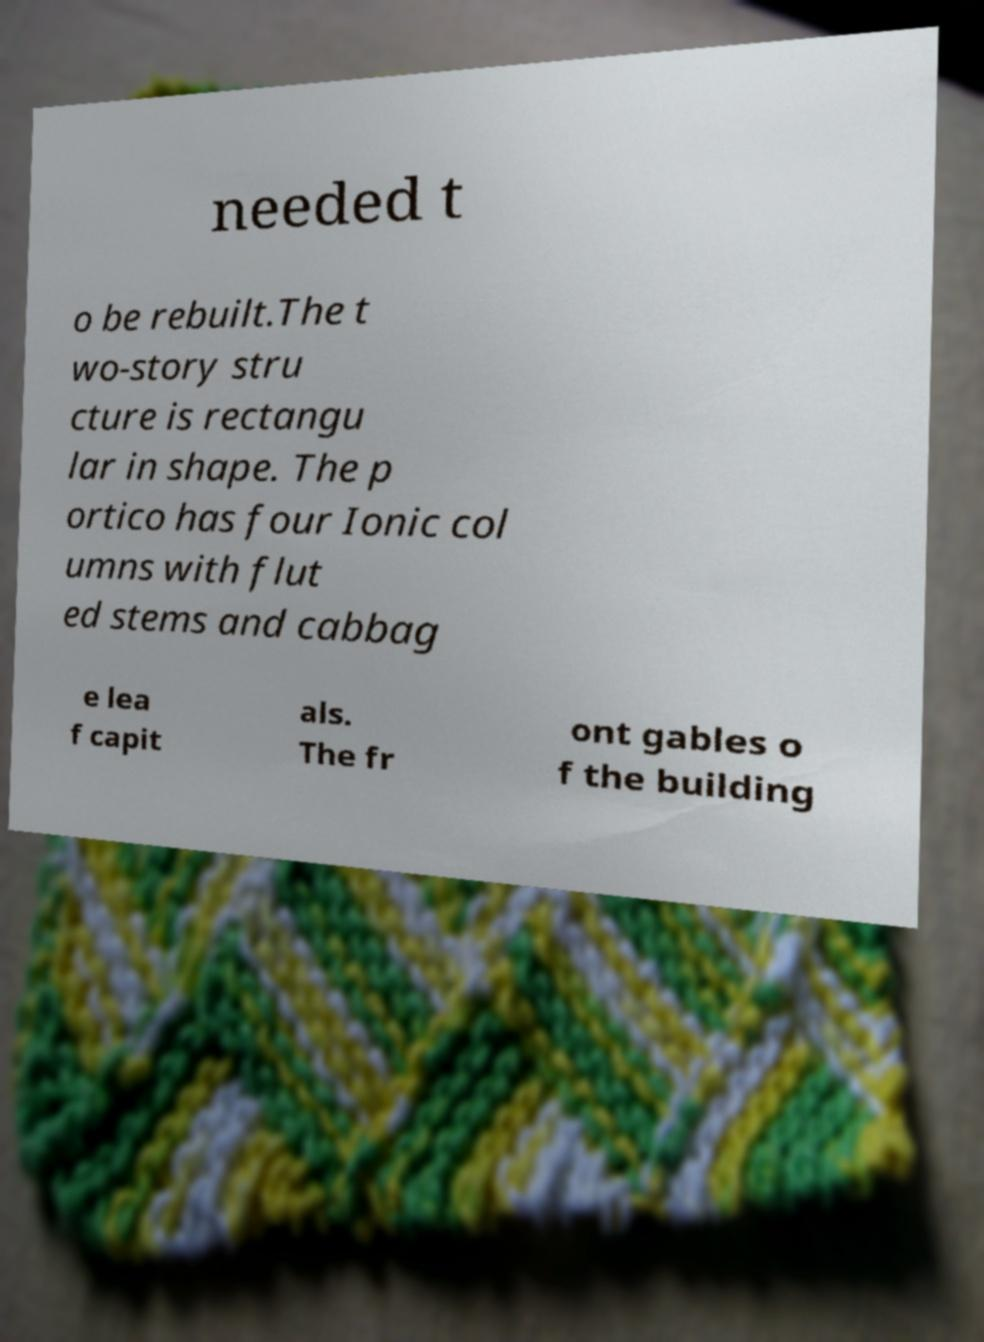Could you assist in decoding the text presented in this image and type it out clearly? needed t o be rebuilt.The t wo-story stru cture is rectangu lar in shape. The p ortico has four Ionic col umns with flut ed stems and cabbag e lea f capit als. The fr ont gables o f the building 